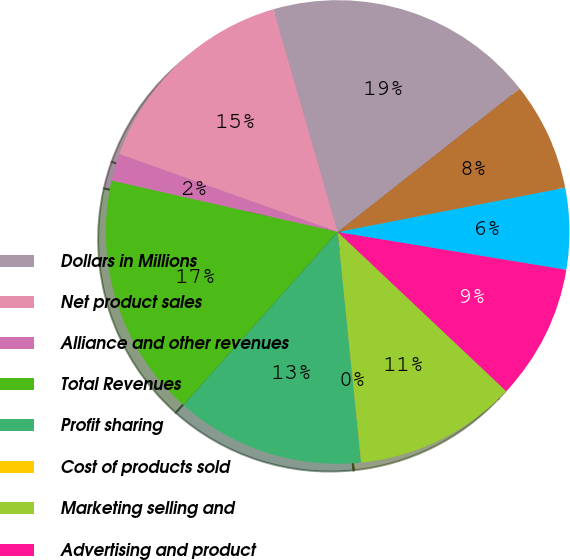Convert chart. <chart><loc_0><loc_0><loc_500><loc_500><pie_chart><fcel>Dollars in Millions<fcel>Net product sales<fcel>Alliance and other revenues<fcel>Total Revenues<fcel>Profit sharing<fcel>Cost of products sold<fcel>Marketing selling and<fcel>Advertising and product<fcel>Research and development<fcel>Amortization of deferred<nl><fcel>18.85%<fcel>15.08%<fcel>1.9%<fcel>16.97%<fcel>13.2%<fcel>0.02%<fcel>11.32%<fcel>9.44%<fcel>5.67%<fcel>7.55%<nl></chart> 